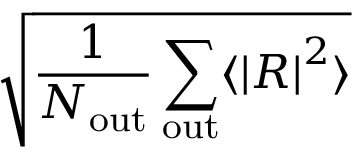Convert formula to latex. <formula><loc_0><loc_0><loc_500><loc_500>\sqrt { \frac { 1 } { N _ { o u t } } \sum _ { o u t } \langle \left | R \right | ^ { 2 } \rangle }</formula> 